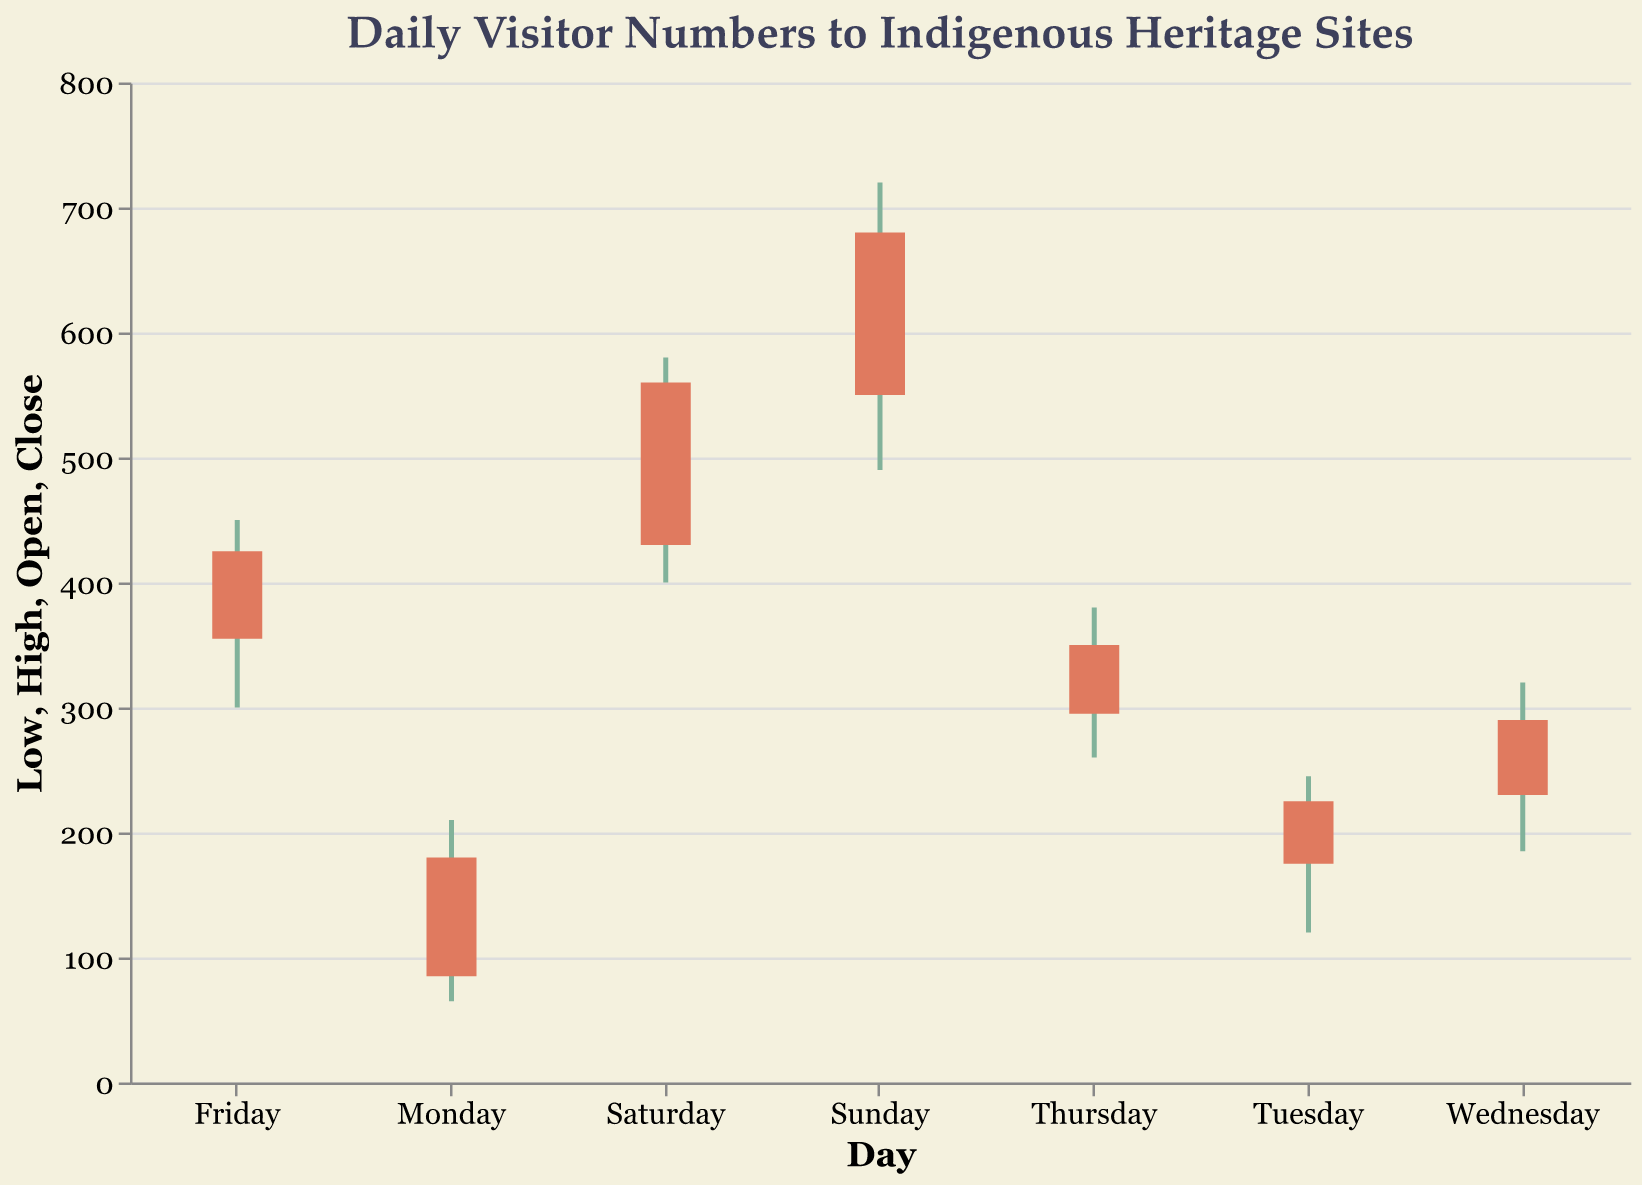What is the highest number of visitors on Sunday? The figure shows the highest number of visitors for each day. On Sunday, the high value is indicated at 720.
Answer: 720 What was the opening number of visitors on Wednesday? The figure shows the opening number of visitors each day. On Wednesday, the opening value is 230.
Answer: 230 How many days saw the number of visitors peak above 300? Review the high values for each day: Monday (210), Tuesday (245), Wednesday (320), Thursday (380), Friday (450), Saturday (580), and Sunday (720). So, Wednesday, Thursday, Friday, Saturday, and Sunday are the days with peaks above 300.
Answer: 5 Which day had the lowest closing number of visitors? The close values for each day are: Monday (180), Tuesday (225), Wednesday (290), Thursday (350), Friday (425), Saturday (560), and Sunday (680). Monday has the lowest closing value.
Answer: Monday What is the difference between the highest and lowest number of visitors on Friday? The high value on Friday is 450 and the low value is 300. The difference is 450 - 300.
Answer: 150 Did the number of visitors increase or decrease from Monday to Tuesday? Compare the closing value of Monday (180) with the opening value of Tuesday (175). Since the opening number of visitors on Tuesday is less than the closing number on Monday, the number decreased.
Answer: Decrease On which day did the number of visitors fluctuate the most? Calculate the range (high - low) for each day: Monday (145), Tuesday (125), Wednesday (135), Thursday (120), Friday (150), Saturday (180), Sunday (230). Sunday had the highest fluctuation.
Answer: Sunday How many days had a higher closing number of visitors than the opening number? Days with higher closing than opening numbers are: Monday (180 > 85), Tuesday (225 > 175), Wednesday (290 > 230), Thursday (350 > 295), Friday (425 > 355), Saturday (560 > 430), Sunday (680 > 550). This condition is true for all days.
Answer: 7 What was the average closing number of visitors over the week? Sum the closing numbers: 180 + 225 + 290 + 350 + 425 + 560 + 680 = 2710. Divide by 7 (number of days) to get the average: 2710 / 7.
Answer: 387.14 